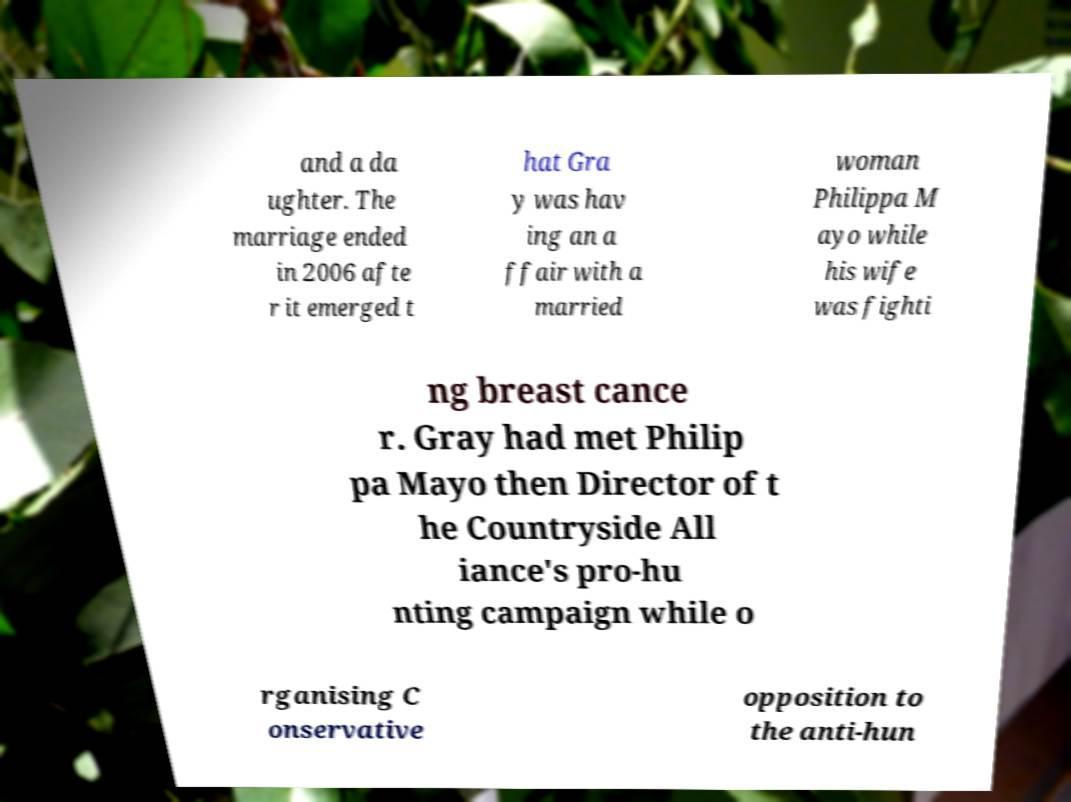Please read and relay the text visible in this image. What does it say? and a da ughter. The marriage ended in 2006 afte r it emerged t hat Gra y was hav ing an a ffair with a married woman Philippa M ayo while his wife was fighti ng breast cance r. Gray had met Philip pa Mayo then Director of t he Countryside All iance's pro-hu nting campaign while o rganising C onservative opposition to the anti-hun 